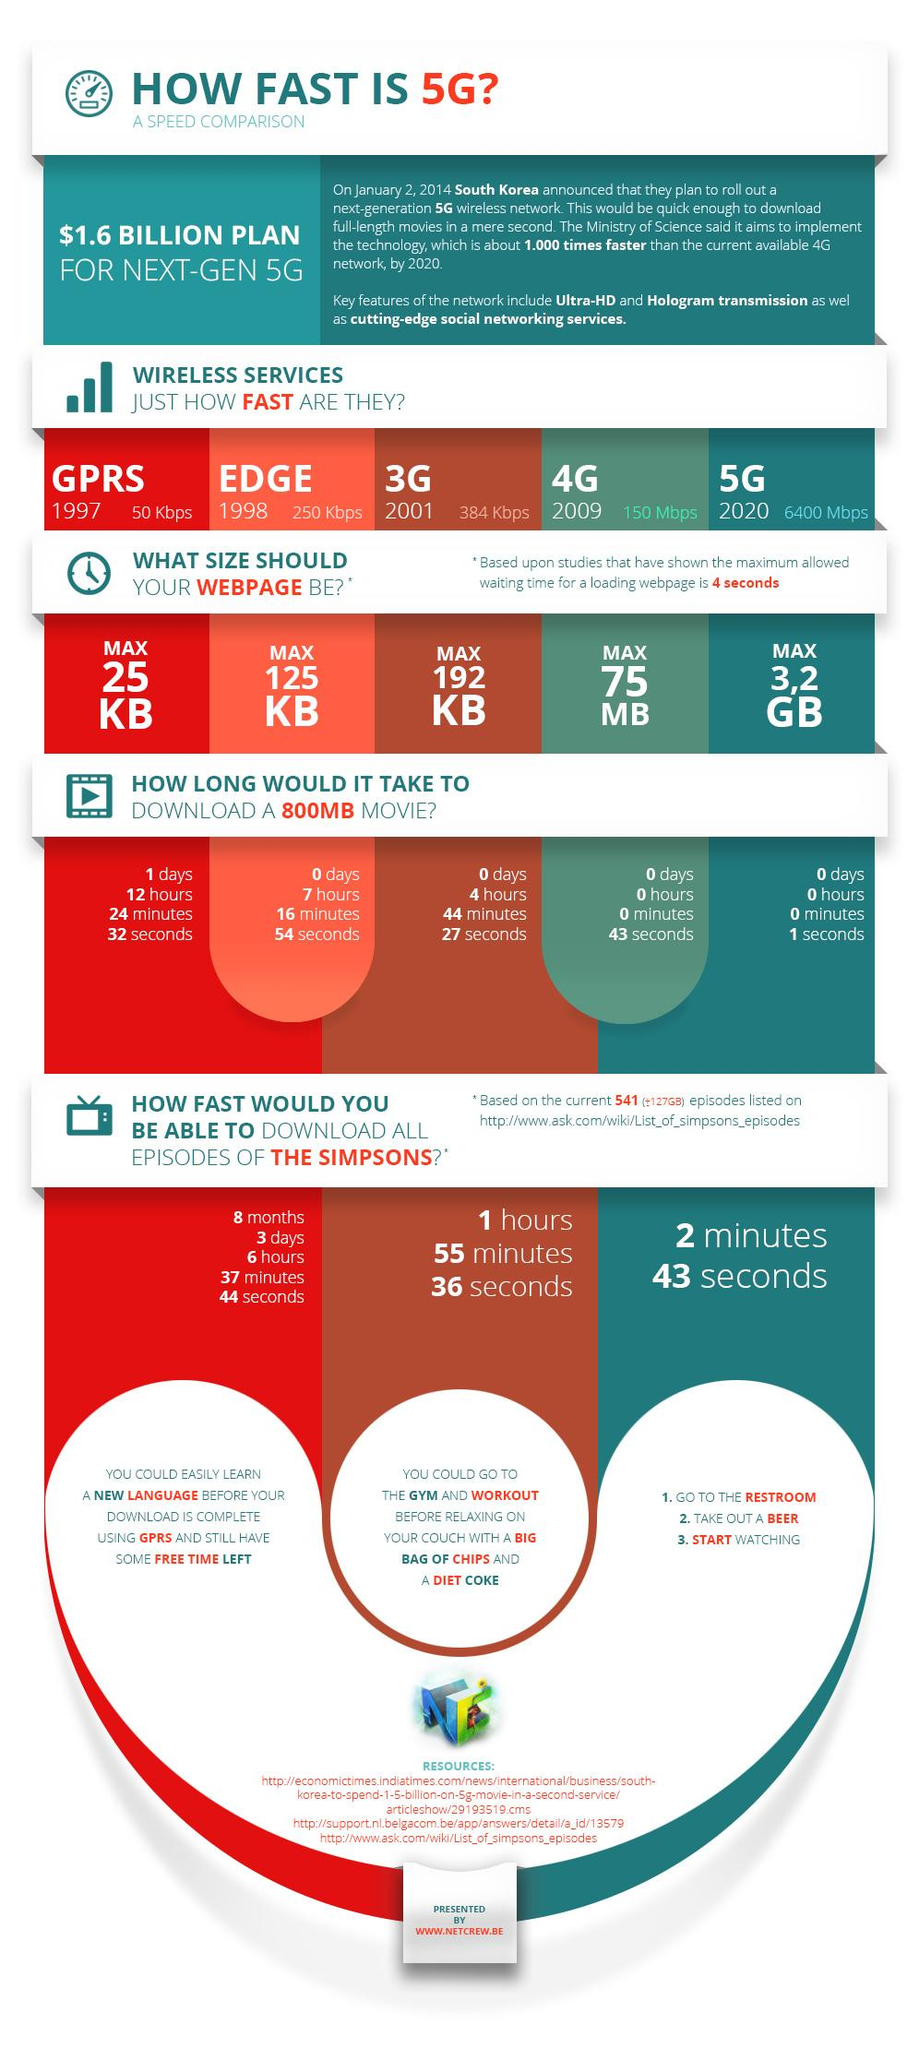List a handful of essential elements in this visual. Thirty-three resources are listed. 